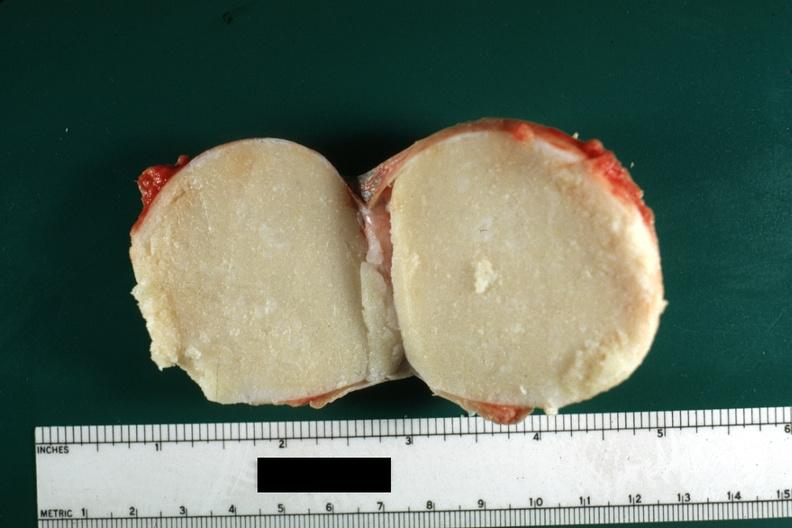where is this?
Answer the question using a single word or phrase. Skin 